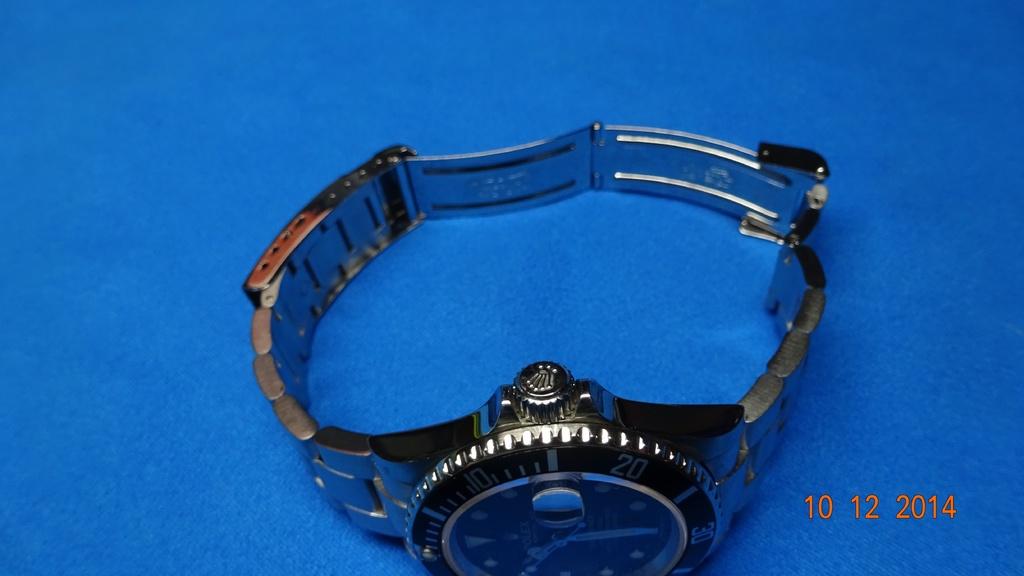When was this photo taken?
Offer a very short reply. 10 12 2014. What numbers are visible on the watch?
Make the answer very short. 10 20 30. 